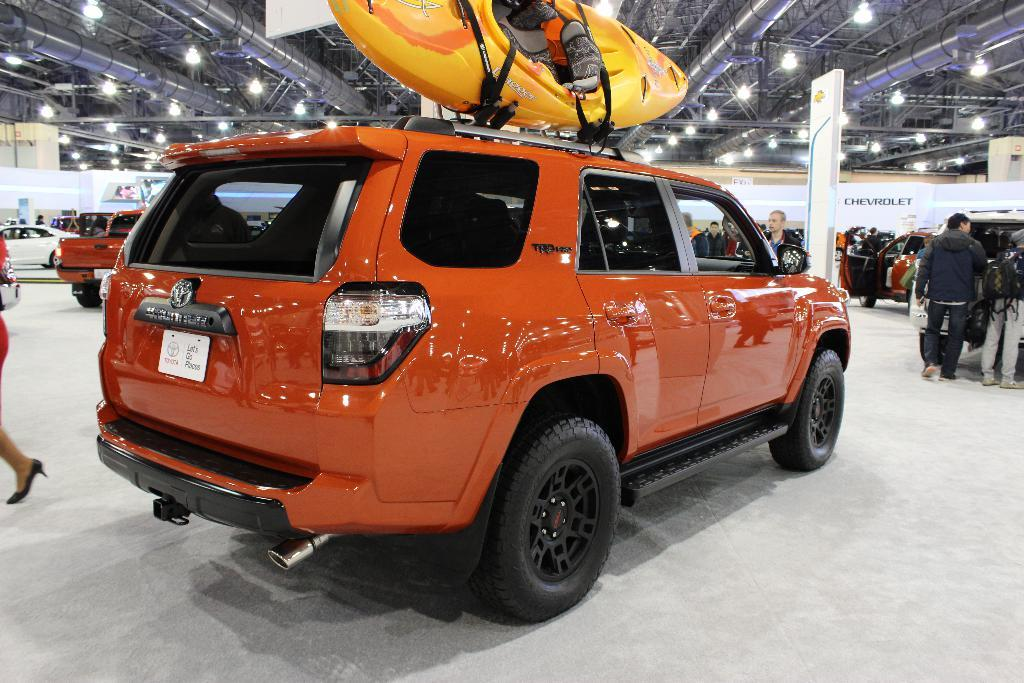What can be seen on the platform in the image? There are vehicles on the platform in the image. Can you describe the people visible in the image? There are people visible in the image. What type of illumination is present in the image? There are lights in the image. What objects can be seen with writing or information on them? There are boards in the image. What type of harmony can be heard between the vehicles in the image? There is no audible harmony in the image, as it is a still image and not a video or audio recording. 